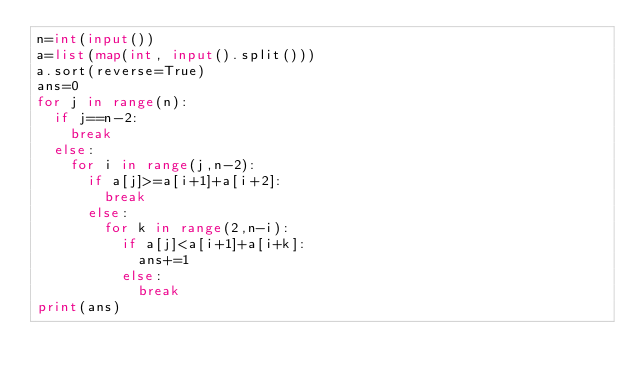Convert code to text. <code><loc_0><loc_0><loc_500><loc_500><_Python_>n=int(input())
a=list(map(int, input().split()))
a.sort(reverse=True)
ans=0
for j in range(n):
	if j==n-2:
		break
	else:
		for i in range(j,n-2):
			if a[j]>=a[i+1]+a[i+2]:
				break
			else:
				for k in range(2,n-i):
					if a[j]<a[i+1]+a[i+k]:
						ans+=1			
					else:
						break
print(ans)</code> 